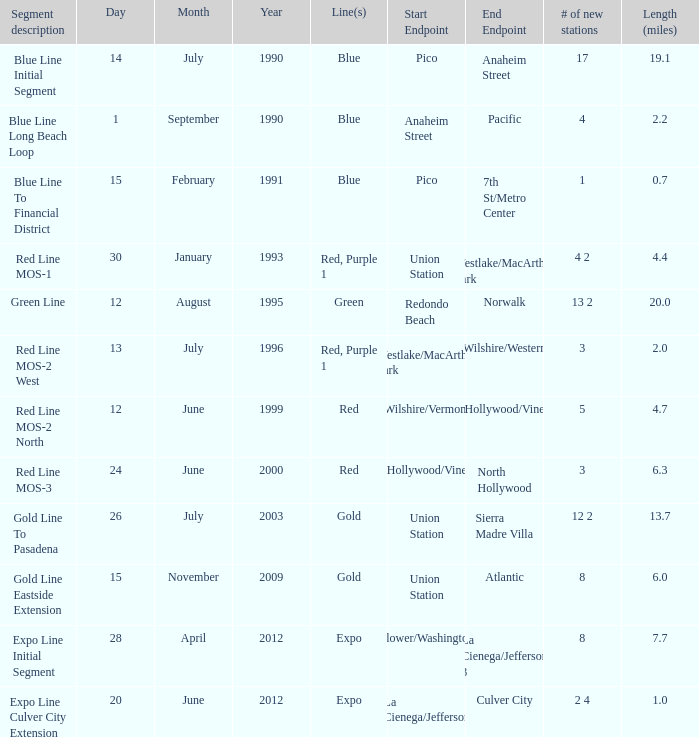What is the opening date for the segment description red line mos-2 north? June 12, 1999. 